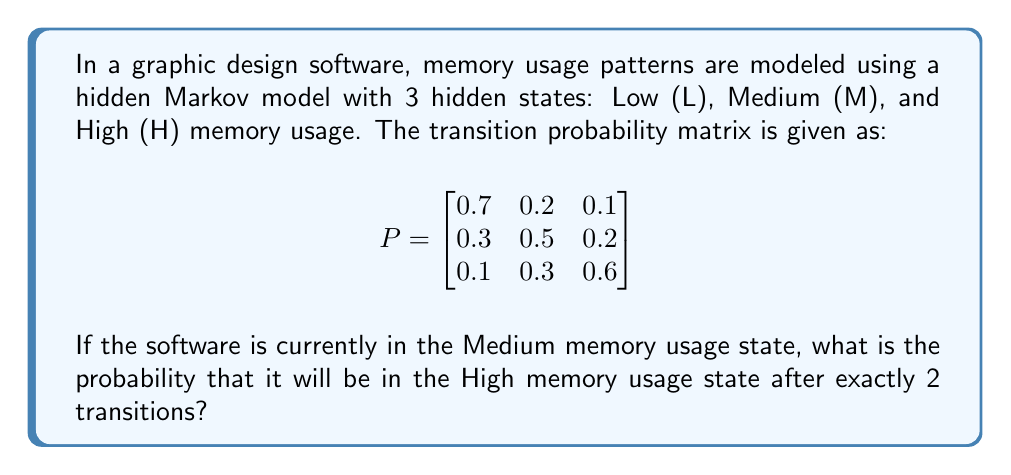What is the answer to this math problem? To solve this problem, we need to use the Chapman-Kolmogorov equations and matrix multiplication. Let's break it down step-by-step:

1. We start in the Medium (M) state, which corresponds to the second row of the transition probability matrix.

2. We need to calculate the probability of being in the High (H) state after 2 transitions. This is equivalent to calculating the $(M, H)$ entry of the matrix $P^2$.

3. To get $P^2$, we multiply the matrix $P$ by itself:

   $$P^2 = P \times P = \begin{bmatrix}
   0.7 & 0.2 & 0.1 \\
   0.3 & 0.5 & 0.2 \\
   0.1 & 0.3 & 0.6
   \end{bmatrix} \times \begin{bmatrix}
   0.7 & 0.2 & 0.1 \\
   0.3 & 0.5 & 0.2 \\
   0.1 & 0.3 & 0.6
   \end{bmatrix}$$

4. Performing the matrix multiplication:

   $$P^2 = \begin{bmatrix}
   0.56 & 0.29 & 0.15 \\
   0.37 & 0.41 & 0.22 \\
   0.22 & 0.39 & 0.39
   \end{bmatrix}$$

5. The probability we're looking for is the $(M, H)$ entry of $P^2$, which is the element in the second row, third column of the resulting matrix.

Therefore, the probability of being in the High memory usage state after exactly 2 transitions, starting from the Medium state, is 0.22 or 22%.
Answer: 0.22 